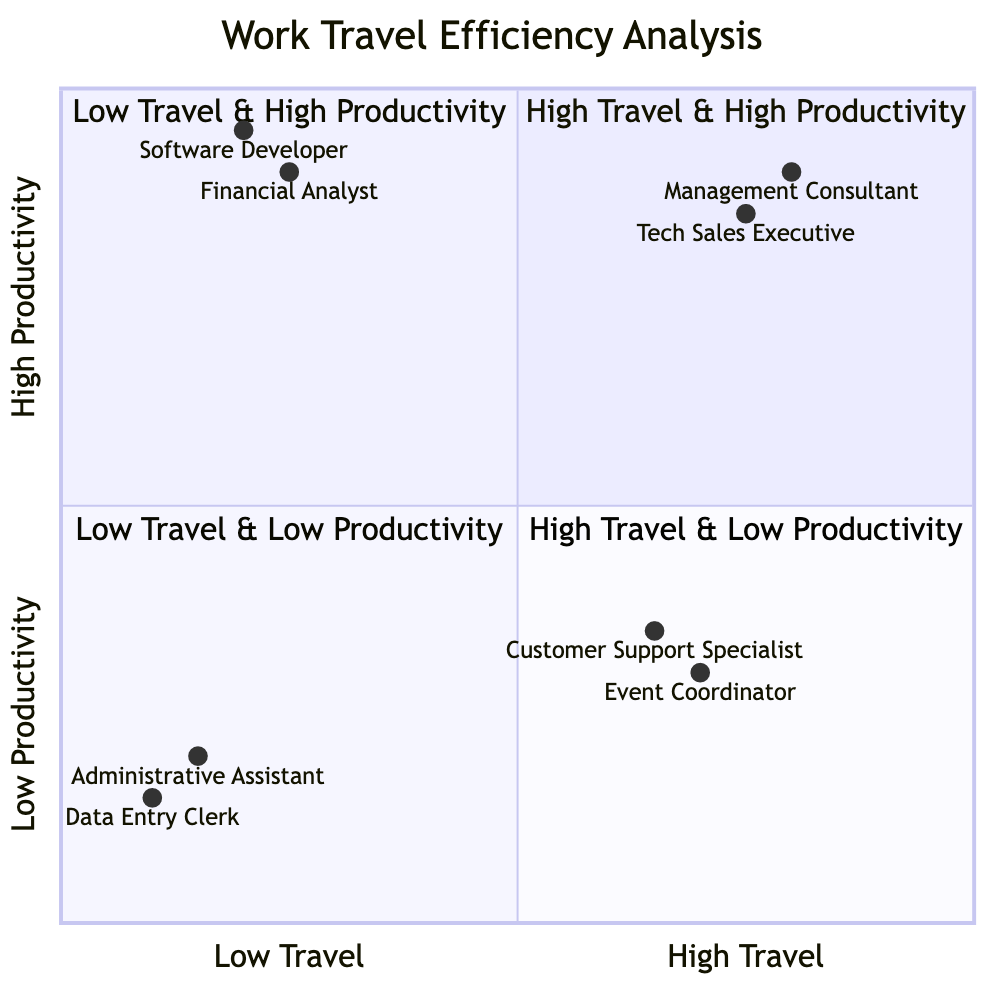What's in the High Travel & High Productivity quadrant? The examples in this quadrant include a Management Consultant from McKinsey & Company and a Tech Sales Executive from Microsoft, both of whom have frequent travel and high productivity related tasks.
Answer: Management Consultant, Tech Sales Executive How many professions are categorized as High Travel & Low Productivity? There are two professions listed in the High Travel & Low Productivity quadrant: Event Coordinator and Customer Support Specialist.
Answer: 2 Which profession has the highest productivity score? The Software Developer from Google has the highest productivity score at 0.95, which places them in the Low Travel & High Productivity quadrant.
Answer: Software Developer What is the travel frequency of the Administrative Assistant? The Administrative Assistant has a travel frequency score of 0.15, indicating low travel frequency, which places them in the Low Travel & Low Productivity quadrant.
Answer: 0.15 Compare the travel frequency of the Financial Analyst and the Customer Support Specialist. The Financial Analyst has a travel frequency score of 0.25, while the Customer Support Specialist has a travel frequency score of 0.65. This indicates that the Customer Support Specialist travels more frequently than the Financial Analyst.
Answer: Customer Support Specialist How many professions have both low travel and low productivity? There are two professions listed in the Low Travel & Low Productivity quadrant: Administrative Assistant and Data Entry Clerk, which signifies that both have low scores in travel frequency and productivity.
Answer: 2 Which profession travels the least? The Data Entry Clerk from Amazon has the lowest travel frequency score of 0.1, making this profession the one that travels the least among the listed examples.
Answer: Data Entry Clerk What relationship exists between high travel frequency and productivity for the Tech Sales Executive? The Tech Sales Executive has a high travel frequency score of 0.75 and a high productivity score of 0.85, indicating that they effectively combine frequent travel with high productivity tasks.
Answer: High relationship Which quadrant contains professions that frequently travel but are less productive? The High Travel & Low Productivity quadrant contains the professions of Event Coordinator and Customer Support Specialist, which signifies that these roles are marked by frequent travel yet lower productivity levels.
Answer: High Travel & Low Productivity quadrant 